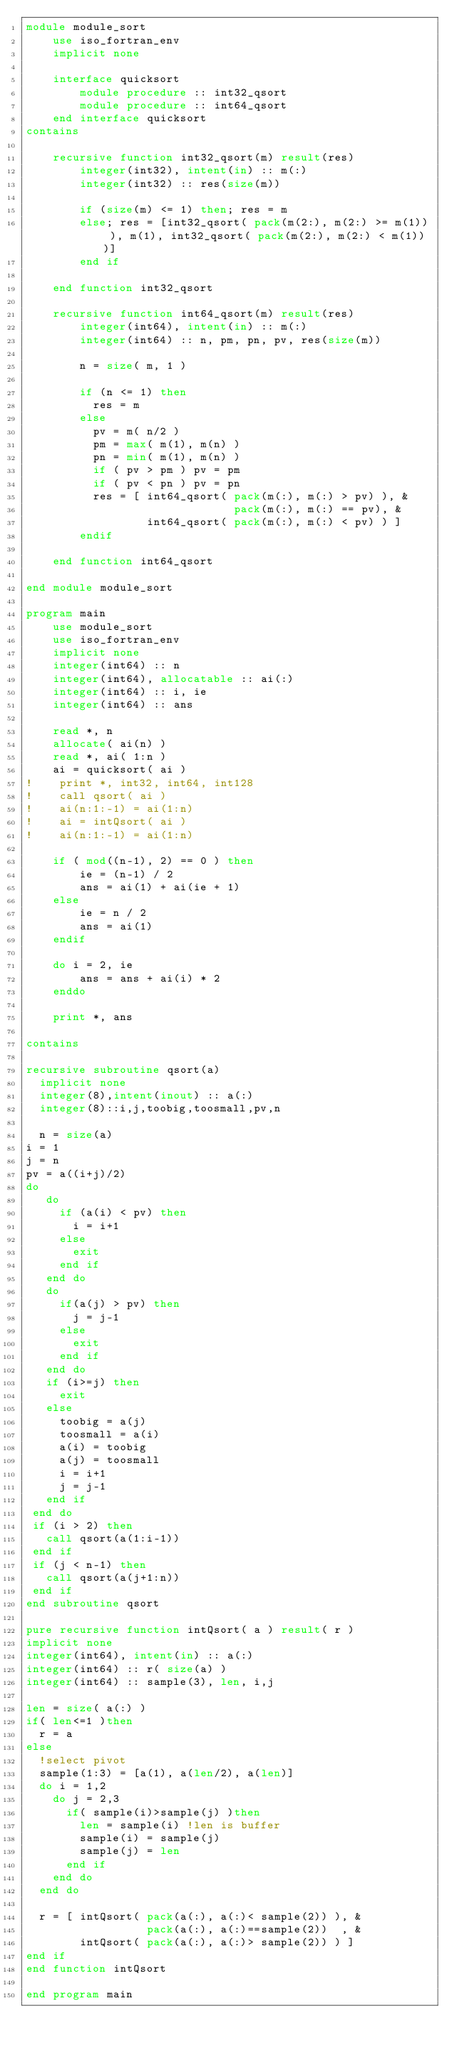<code> <loc_0><loc_0><loc_500><loc_500><_FORTRAN_>module module_sort
    use iso_fortran_env
    implicit none

    interface quicksort
        module procedure :: int32_qsort
        module procedure :: int64_qsort
    end interface quicksort
contains

    recursive function int32_qsort(m) result(res)
        integer(int32), intent(in) :: m(:)
        integer(int32) :: res(size(m))

        if (size(m) <= 1) then; res = m
        else; res = [int32_qsort( pack(m(2:), m(2:) >= m(1)) ), m(1), int32_qsort( pack(m(2:), m(2:) < m(1)) )]
        end if

    end function int32_qsort

    recursive function int64_qsort(m) result(res)
        integer(int64), intent(in) :: m(:)
        integer(int64) :: n, pm, pn, pv, res(size(m))

        n = size( m, 1 )

        if (n <= 1) then
          res = m
        else
          pv = m( n/2 )
          pm = max( m(1), m(n) )
          pn = min( m(1), m(n) )
          if ( pv > pm ) pv = pm
          if ( pv < pn ) pv = pn
          res = [ int64_qsort( pack(m(:), m(:) > pv) ), &
                               pack(m(:), m(:) == pv), &
                  int64_qsort( pack(m(:), m(:) < pv) ) ]
        endif

    end function int64_qsort

end module module_sort

program main
    use module_sort
    use iso_fortran_env
    implicit none
    integer(int64) :: n
    integer(int64), allocatable :: ai(:)
    integer(int64) :: i, ie
    integer(int64) :: ans

    read *, n
    allocate( ai(n) )
    read *, ai( 1:n )
    ai = quicksort( ai )
!    print *, int32, int64, int128
!    call qsort( ai )
!    ai(n:1:-1) = ai(1:n)
!    ai = intQsort( ai )
!    ai(n:1:-1) = ai(1:n)

    if ( mod((n-1), 2) == 0 ) then
        ie = (n-1) / 2
        ans = ai(1) + ai(ie + 1)
    else
        ie = n / 2
        ans = ai(1)
    endif

    do i = 2, ie
        ans = ans + ai(i) * 2
    enddo

    print *, ans

contains

recursive subroutine qsort(a)
  implicit none
  integer(8),intent(inout) :: a(:)
  integer(8)::i,j,toobig,toosmall,pv,n

  n = size(a)
i = 1
j = n
pv = a((i+j)/2)
do
   do
     if (a(i) < pv) then
       i = i+1
     else
       exit
     end if
   end do
   do
     if(a(j) > pv) then
       j = j-1
     else
       exit
     end if
   end do
   if (i>=j) then
     exit
   else
     toobig = a(j)
     toosmall = a(i)
     a(i) = toobig
     a(j) = toosmall
     i = i+1
     j = j-1
   end if
 end do
 if (i > 2) then
   call qsort(a(1:i-1))
 end if
 if (j < n-1) then
   call qsort(a(j+1:n))
 end if
end subroutine qsort

pure recursive function intQsort( a ) result( r )
implicit none
integer(int64), intent(in) :: a(:)
integer(int64) :: r( size(a) )
integer(int64) :: sample(3), len, i,j

len = size( a(:) )
if( len<=1 )then
  r = a
else
  !select pivot
  sample(1:3) = [a(1), a(len/2), a(len)]
  do i = 1,2
    do j = 2,3
      if( sample(i)>sample(j) )then
        len = sample(i) !len is buffer
        sample(i) = sample(j)
        sample(j) = len
      end if
    end do
  end do
  
  r = [ intQsort( pack(a(:), a(:)< sample(2)) ), &
                  pack(a(:), a(:)==sample(2))  , &
        intQsort( pack(a(:), a(:)> sample(2)) ) ]
end if
end function intQsort

end program main</code> 